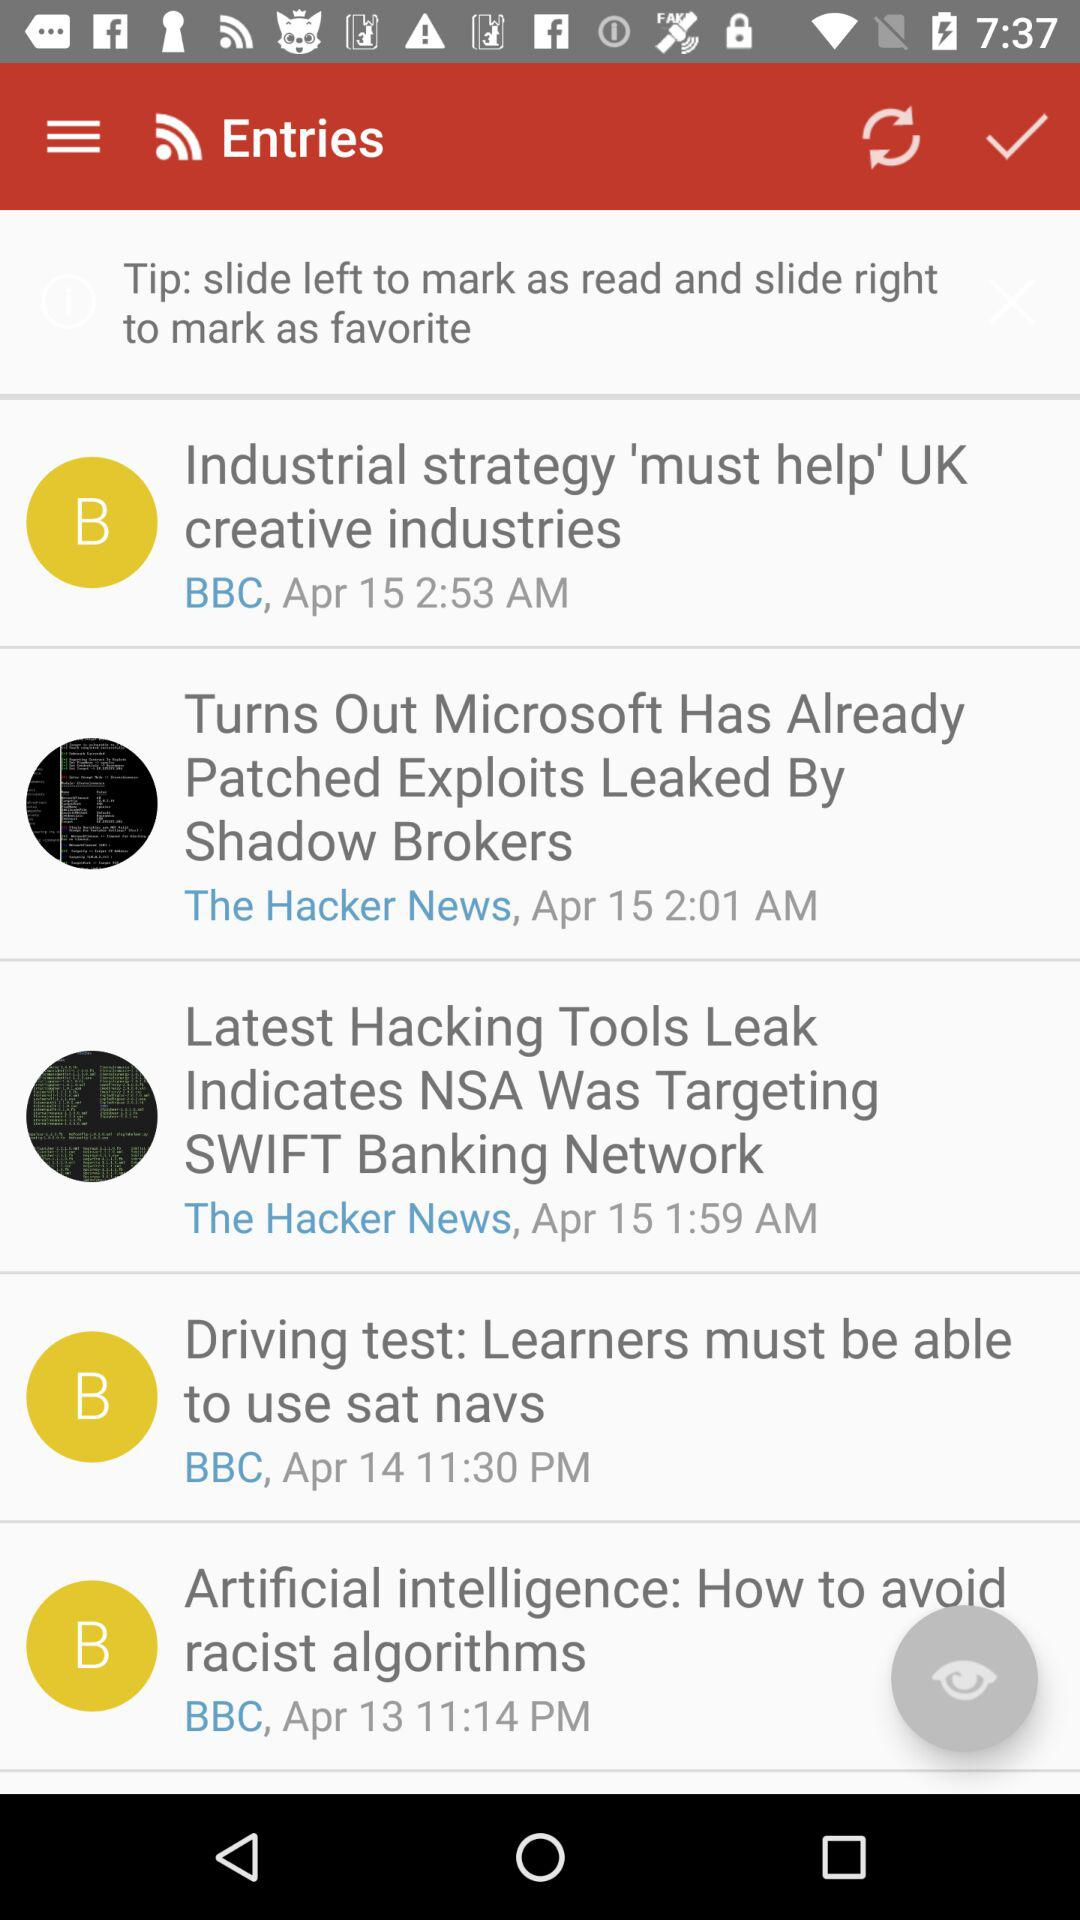What is the time of the entry "Driving test: Learners must be able to use sat navs"? The time of the entry is 11:30 PM. 